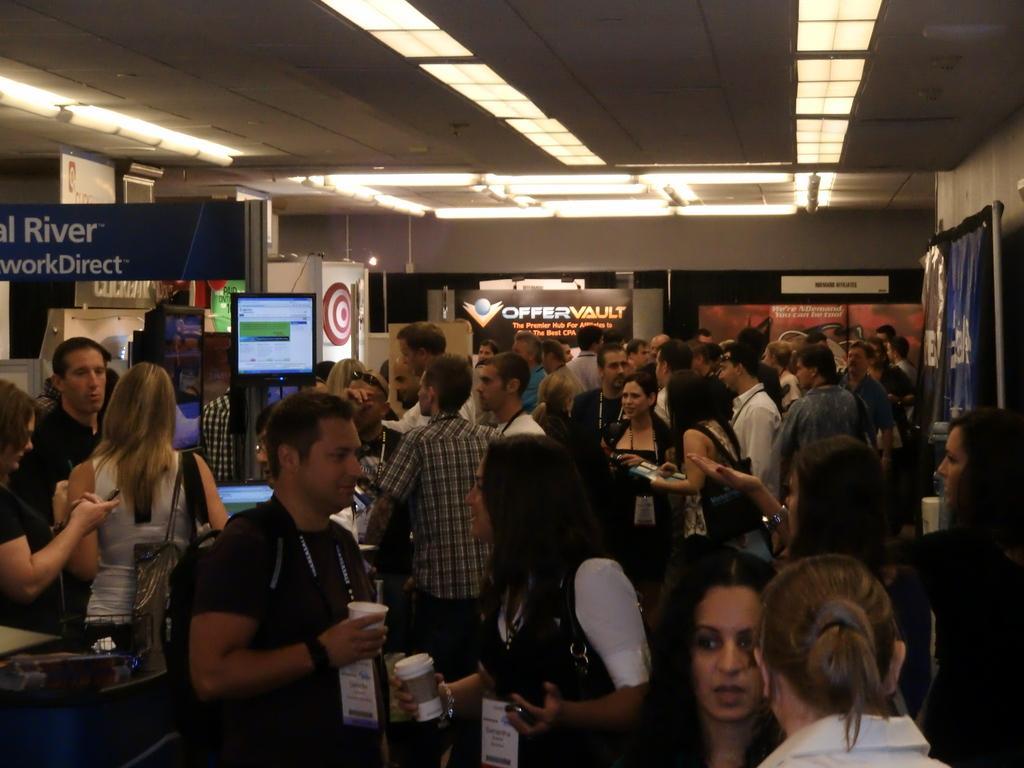Could you give a brief overview of what you see in this image? In the foreground of this image, there are many people standing where few are holding glasses and few are wearing bags. We can also see few banners, wall and the lights to the ceiling. 